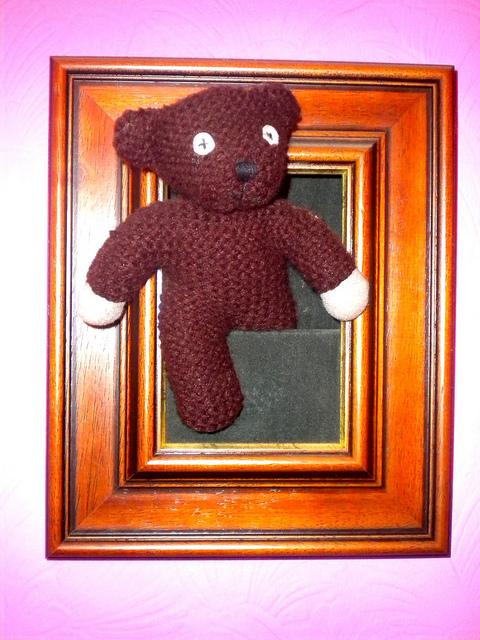Would this be hung in a child's room?
Answer briefly. Yes. What color is the frame on the wall?
Keep it brief. Brown. What animal is the toy?
Keep it brief. Bear. 